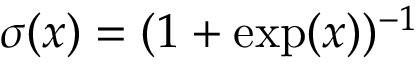<formula> <loc_0><loc_0><loc_500><loc_500>\sigma ( x ) = ( 1 + \exp ( x ) ) ^ { - 1 }</formula> 